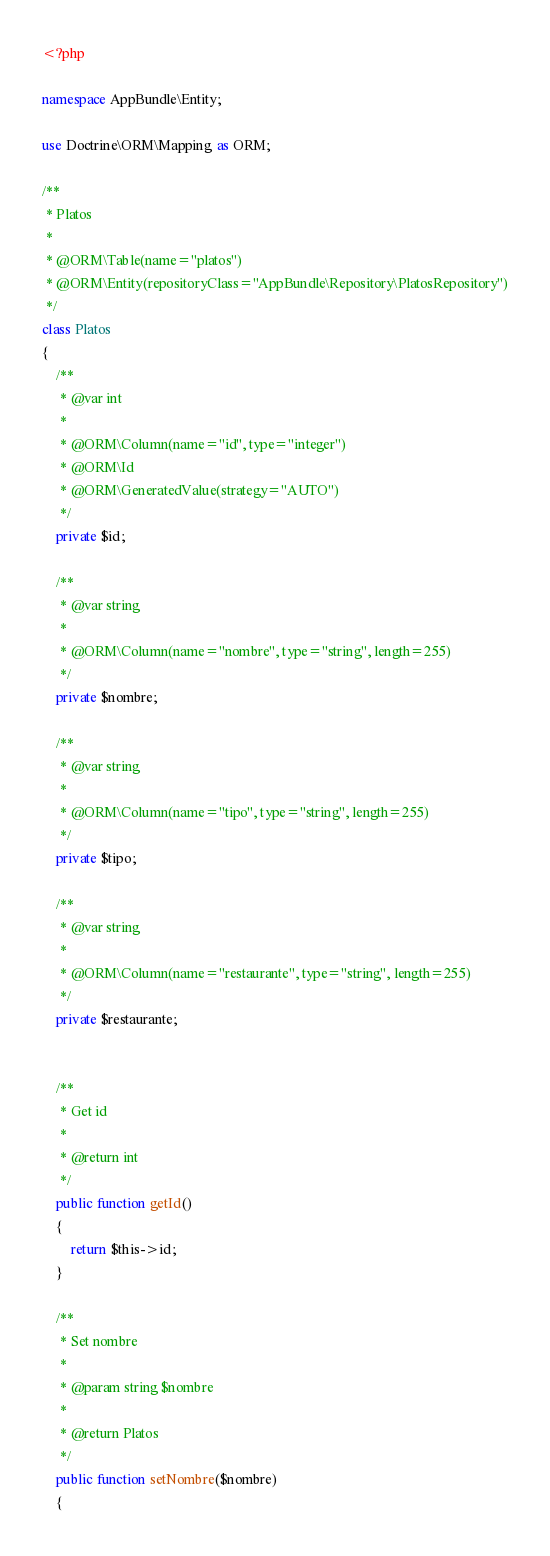<code> <loc_0><loc_0><loc_500><loc_500><_PHP_><?php

namespace AppBundle\Entity;

use Doctrine\ORM\Mapping as ORM;

/**
 * Platos
 *
 * @ORM\Table(name="platos")
 * @ORM\Entity(repositoryClass="AppBundle\Repository\PlatosRepository")
 */
class Platos
{
    /**
     * @var int
     *
     * @ORM\Column(name="id", type="integer")
     * @ORM\Id
     * @ORM\GeneratedValue(strategy="AUTO")
     */
    private $id;

    /**
     * @var string
     *
     * @ORM\Column(name="nombre", type="string", length=255)
     */
    private $nombre;

    /**
     * @var string
     *
     * @ORM\Column(name="tipo", type="string", length=255)
     */
    private $tipo;

    /**
     * @var string
     *
     * @ORM\Column(name="restaurante", type="string", length=255)
     */
    private $restaurante;


    /**
     * Get id
     *
     * @return int
     */
    public function getId()
    {
        return $this->id;
    }

    /**
     * Set nombre
     *
     * @param string $nombre
     *
     * @return Platos
     */
    public function setNombre($nombre)
    {</code> 